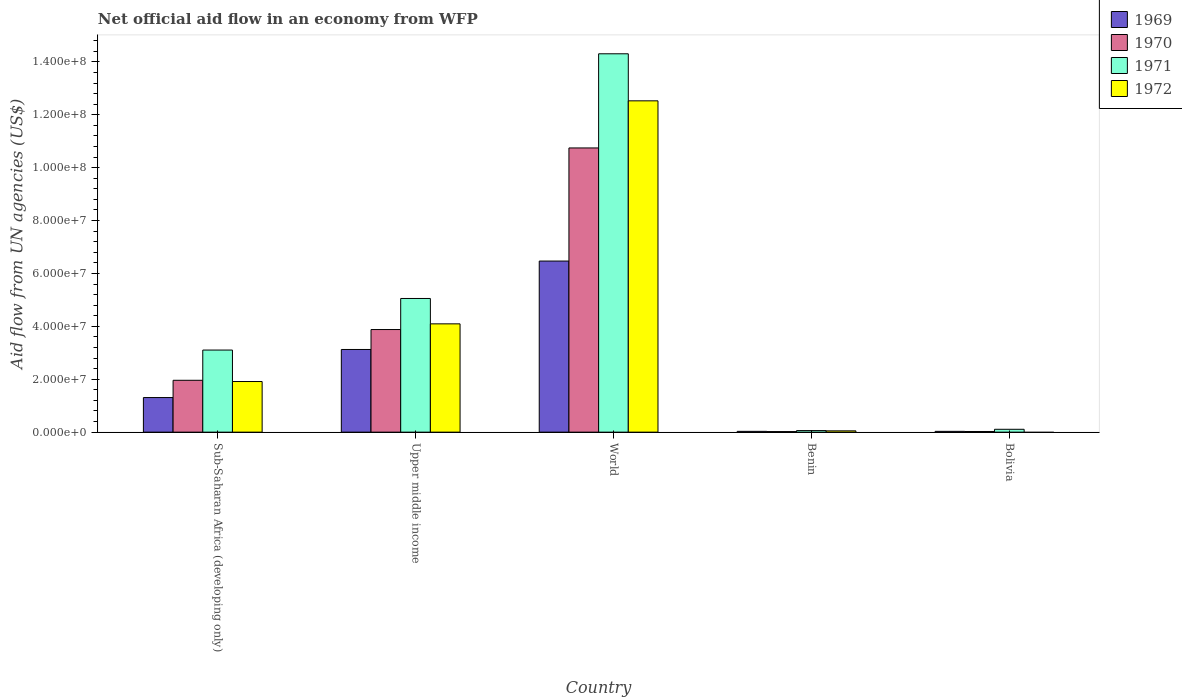Are the number of bars per tick equal to the number of legend labels?
Provide a short and direct response. No. How many bars are there on the 4th tick from the left?
Give a very brief answer. 4. How many bars are there on the 5th tick from the right?
Your response must be concise. 4. What is the label of the 1st group of bars from the left?
Provide a short and direct response. Sub-Saharan Africa (developing only). What is the net official aid flow in 1972 in Benin?
Keep it short and to the point. 4.90e+05. Across all countries, what is the maximum net official aid flow in 1970?
Keep it short and to the point. 1.07e+08. Across all countries, what is the minimum net official aid flow in 1970?
Your answer should be compact. 2.10e+05. In which country was the net official aid flow in 1971 maximum?
Your response must be concise. World. What is the total net official aid flow in 1972 in the graph?
Provide a short and direct response. 1.86e+08. What is the difference between the net official aid flow in 1969 in Sub-Saharan Africa (developing only) and that in Upper middle income?
Your answer should be very brief. -1.82e+07. What is the difference between the net official aid flow in 1970 in Bolivia and the net official aid flow in 1972 in Upper middle income?
Your answer should be very brief. -4.07e+07. What is the average net official aid flow in 1969 per country?
Your answer should be very brief. 2.19e+07. What is the difference between the net official aid flow of/in 1970 and net official aid flow of/in 1969 in World?
Offer a very short reply. 4.28e+07. In how many countries, is the net official aid flow in 1972 greater than 72000000 US$?
Your answer should be compact. 1. What is the ratio of the net official aid flow in 1971 in Sub-Saharan Africa (developing only) to that in World?
Your answer should be very brief. 0.22. Is the difference between the net official aid flow in 1970 in Bolivia and World greater than the difference between the net official aid flow in 1969 in Bolivia and World?
Offer a very short reply. No. What is the difference between the highest and the second highest net official aid flow in 1972?
Give a very brief answer. 1.06e+08. What is the difference between the highest and the lowest net official aid flow in 1971?
Provide a succinct answer. 1.42e+08. Is it the case that in every country, the sum of the net official aid flow in 1970 and net official aid flow in 1972 is greater than the sum of net official aid flow in 1971 and net official aid flow in 1969?
Your answer should be very brief. No. Is it the case that in every country, the sum of the net official aid flow in 1972 and net official aid flow in 1969 is greater than the net official aid flow in 1971?
Offer a very short reply. No. How many bars are there?
Ensure brevity in your answer.  19. How many countries are there in the graph?
Offer a very short reply. 5. What is the difference between two consecutive major ticks on the Y-axis?
Offer a very short reply. 2.00e+07. Does the graph contain any zero values?
Provide a short and direct response. Yes. How many legend labels are there?
Offer a terse response. 4. What is the title of the graph?
Your response must be concise. Net official aid flow in an economy from WFP. Does "1980" appear as one of the legend labels in the graph?
Your response must be concise. No. What is the label or title of the X-axis?
Provide a succinct answer. Country. What is the label or title of the Y-axis?
Your answer should be very brief. Aid flow from UN agencies (US$). What is the Aid flow from UN agencies (US$) in 1969 in Sub-Saharan Africa (developing only)?
Offer a terse response. 1.31e+07. What is the Aid flow from UN agencies (US$) of 1970 in Sub-Saharan Africa (developing only)?
Provide a short and direct response. 1.96e+07. What is the Aid flow from UN agencies (US$) of 1971 in Sub-Saharan Africa (developing only)?
Make the answer very short. 3.10e+07. What is the Aid flow from UN agencies (US$) in 1972 in Sub-Saharan Africa (developing only)?
Offer a terse response. 1.91e+07. What is the Aid flow from UN agencies (US$) in 1969 in Upper middle income?
Your response must be concise. 3.13e+07. What is the Aid flow from UN agencies (US$) in 1970 in Upper middle income?
Make the answer very short. 3.88e+07. What is the Aid flow from UN agencies (US$) in 1971 in Upper middle income?
Your answer should be compact. 5.05e+07. What is the Aid flow from UN agencies (US$) of 1972 in Upper middle income?
Give a very brief answer. 4.10e+07. What is the Aid flow from UN agencies (US$) of 1969 in World?
Keep it short and to the point. 6.47e+07. What is the Aid flow from UN agencies (US$) in 1970 in World?
Your answer should be compact. 1.07e+08. What is the Aid flow from UN agencies (US$) in 1971 in World?
Your response must be concise. 1.43e+08. What is the Aid flow from UN agencies (US$) in 1972 in World?
Give a very brief answer. 1.25e+08. What is the Aid flow from UN agencies (US$) in 1969 in Benin?
Keep it short and to the point. 3.00e+05. What is the Aid flow from UN agencies (US$) of 1970 in Benin?
Your response must be concise. 2.10e+05. What is the Aid flow from UN agencies (US$) of 1971 in Benin?
Your answer should be very brief. 5.90e+05. What is the Aid flow from UN agencies (US$) of 1972 in Benin?
Ensure brevity in your answer.  4.90e+05. What is the Aid flow from UN agencies (US$) in 1971 in Bolivia?
Your answer should be very brief. 1.08e+06. Across all countries, what is the maximum Aid flow from UN agencies (US$) in 1969?
Give a very brief answer. 6.47e+07. Across all countries, what is the maximum Aid flow from UN agencies (US$) in 1970?
Your answer should be compact. 1.07e+08. Across all countries, what is the maximum Aid flow from UN agencies (US$) in 1971?
Provide a succinct answer. 1.43e+08. Across all countries, what is the maximum Aid flow from UN agencies (US$) of 1972?
Your response must be concise. 1.25e+08. Across all countries, what is the minimum Aid flow from UN agencies (US$) of 1970?
Keep it short and to the point. 2.10e+05. Across all countries, what is the minimum Aid flow from UN agencies (US$) in 1971?
Ensure brevity in your answer.  5.90e+05. Across all countries, what is the minimum Aid flow from UN agencies (US$) of 1972?
Your answer should be very brief. 0. What is the total Aid flow from UN agencies (US$) of 1969 in the graph?
Your response must be concise. 1.10e+08. What is the total Aid flow from UN agencies (US$) in 1970 in the graph?
Offer a terse response. 1.66e+08. What is the total Aid flow from UN agencies (US$) in 1971 in the graph?
Make the answer very short. 2.26e+08. What is the total Aid flow from UN agencies (US$) of 1972 in the graph?
Provide a short and direct response. 1.86e+08. What is the difference between the Aid flow from UN agencies (US$) in 1969 in Sub-Saharan Africa (developing only) and that in Upper middle income?
Make the answer very short. -1.82e+07. What is the difference between the Aid flow from UN agencies (US$) of 1970 in Sub-Saharan Africa (developing only) and that in Upper middle income?
Offer a terse response. -1.92e+07. What is the difference between the Aid flow from UN agencies (US$) of 1971 in Sub-Saharan Africa (developing only) and that in Upper middle income?
Ensure brevity in your answer.  -1.95e+07. What is the difference between the Aid flow from UN agencies (US$) in 1972 in Sub-Saharan Africa (developing only) and that in Upper middle income?
Make the answer very short. -2.18e+07. What is the difference between the Aid flow from UN agencies (US$) of 1969 in Sub-Saharan Africa (developing only) and that in World?
Make the answer very short. -5.16e+07. What is the difference between the Aid flow from UN agencies (US$) in 1970 in Sub-Saharan Africa (developing only) and that in World?
Your response must be concise. -8.78e+07. What is the difference between the Aid flow from UN agencies (US$) in 1971 in Sub-Saharan Africa (developing only) and that in World?
Your answer should be very brief. -1.12e+08. What is the difference between the Aid flow from UN agencies (US$) of 1972 in Sub-Saharan Africa (developing only) and that in World?
Provide a succinct answer. -1.06e+08. What is the difference between the Aid flow from UN agencies (US$) in 1969 in Sub-Saharan Africa (developing only) and that in Benin?
Provide a succinct answer. 1.28e+07. What is the difference between the Aid flow from UN agencies (US$) in 1970 in Sub-Saharan Africa (developing only) and that in Benin?
Your response must be concise. 1.94e+07. What is the difference between the Aid flow from UN agencies (US$) in 1971 in Sub-Saharan Africa (developing only) and that in Benin?
Offer a very short reply. 3.04e+07. What is the difference between the Aid flow from UN agencies (US$) of 1972 in Sub-Saharan Africa (developing only) and that in Benin?
Provide a short and direct response. 1.86e+07. What is the difference between the Aid flow from UN agencies (US$) of 1969 in Sub-Saharan Africa (developing only) and that in Bolivia?
Your answer should be very brief. 1.28e+07. What is the difference between the Aid flow from UN agencies (US$) of 1970 in Sub-Saharan Africa (developing only) and that in Bolivia?
Offer a terse response. 1.94e+07. What is the difference between the Aid flow from UN agencies (US$) of 1971 in Sub-Saharan Africa (developing only) and that in Bolivia?
Your answer should be compact. 3.00e+07. What is the difference between the Aid flow from UN agencies (US$) in 1969 in Upper middle income and that in World?
Make the answer very short. -3.34e+07. What is the difference between the Aid flow from UN agencies (US$) in 1970 in Upper middle income and that in World?
Your answer should be compact. -6.87e+07. What is the difference between the Aid flow from UN agencies (US$) of 1971 in Upper middle income and that in World?
Provide a short and direct response. -9.25e+07. What is the difference between the Aid flow from UN agencies (US$) of 1972 in Upper middle income and that in World?
Your answer should be compact. -8.43e+07. What is the difference between the Aid flow from UN agencies (US$) in 1969 in Upper middle income and that in Benin?
Your answer should be compact. 3.10e+07. What is the difference between the Aid flow from UN agencies (US$) in 1970 in Upper middle income and that in Benin?
Provide a succinct answer. 3.86e+07. What is the difference between the Aid flow from UN agencies (US$) of 1971 in Upper middle income and that in Benin?
Your answer should be compact. 5.00e+07. What is the difference between the Aid flow from UN agencies (US$) of 1972 in Upper middle income and that in Benin?
Provide a short and direct response. 4.05e+07. What is the difference between the Aid flow from UN agencies (US$) in 1969 in Upper middle income and that in Bolivia?
Offer a terse response. 3.10e+07. What is the difference between the Aid flow from UN agencies (US$) of 1970 in Upper middle income and that in Bolivia?
Your answer should be very brief. 3.86e+07. What is the difference between the Aid flow from UN agencies (US$) of 1971 in Upper middle income and that in Bolivia?
Offer a very short reply. 4.95e+07. What is the difference between the Aid flow from UN agencies (US$) in 1969 in World and that in Benin?
Your answer should be very brief. 6.44e+07. What is the difference between the Aid flow from UN agencies (US$) in 1970 in World and that in Benin?
Provide a succinct answer. 1.07e+08. What is the difference between the Aid flow from UN agencies (US$) in 1971 in World and that in Benin?
Provide a short and direct response. 1.42e+08. What is the difference between the Aid flow from UN agencies (US$) in 1972 in World and that in Benin?
Make the answer very short. 1.25e+08. What is the difference between the Aid flow from UN agencies (US$) in 1969 in World and that in Bolivia?
Your response must be concise. 6.44e+07. What is the difference between the Aid flow from UN agencies (US$) in 1970 in World and that in Bolivia?
Offer a terse response. 1.07e+08. What is the difference between the Aid flow from UN agencies (US$) in 1971 in World and that in Bolivia?
Provide a short and direct response. 1.42e+08. What is the difference between the Aid flow from UN agencies (US$) of 1969 in Benin and that in Bolivia?
Keep it short and to the point. 0. What is the difference between the Aid flow from UN agencies (US$) in 1970 in Benin and that in Bolivia?
Make the answer very short. -4.00e+04. What is the difference between the Aid flow from UN agencies (US$) of 1971 in Benin and that in Bolivia?
Provide a short and direct response. -4.90e+05. What is the difference between the Aid flow from UN agencies (US$) of 1969 in Sub-Saharan Africa (developing only) and the Aid flow from UN agencies (US$) of 1970 in Upper middle income?
Give a very brief answer. -2.57e+07. What is the difference between the Aid flow from UN agencies (US$) in 1969 in Sub-Saharan Africa (developing only) and the Aid flow from UN agencies (US$) in 1971 in Upper middle income?
Offer a very short reply. -3.75e+07. What is the difference between the Aid flow from UN agencies (US$) in 1969 in Sub-Saharan Africa (developing only) and the Aid flow from UN agencies (US$) in 1972 in Upper middle income?
Make the answer very short. -2.79e+07. What is the difference between the Aid flow from UN agencies (US$) of 1970 in Sub-Saharan Africa (developing only) and the Aid flow from UN agencies (US$) of 1971 in Upper middle income?
Make the answer very short. -3.09e+07. What is the difference between the Aid flow from UN agencies (US$) of 1970 in Sub-Saharan Africa (developing only) and the Aid flow from UN agencies (US$) of 1972 in Upper middle income?
Offer a terse response. -2.13e+07. What is the difference between the Aid flow from UN agencies (US$) of 1971 in Sub-Saharan Africa (developing only) and the Aid flow from UN agencies (US$) of 1972 in Upper middle income?
Your response must be concise. -9.91e+06. What is the difference between the Aid flow from UN agencies (US$) in 1969 in Sub-Saharan Africa (developing only) and the Aid flow from UN agencies (US$) in 1970 in World?
Ensure brevity in your answer.  -9.44e+07. What is the difference between the Aid flow from UN agencies (US$) in 1969 in Sub-Saharan Africa (developing only) and the Aid flow from UN agencies (US$) in 1971 in World?
Make the answer very short. -1.30e+08. What is the difference between the Aid flow from UN agencies (US$) in 1969 in Sub-Saharan Africa (developing only) and the Aid flow from UN agencies (US$) in 1972 in World?
Your response must be concise. -1.12e+08. What is the difference between the Aid flow from UN agencies (US$) of 1970 in Sub-Saharan Africa (developing only) and the Aid flow from UN agencies (US$) of 1971 in World?
Make the answer very short. -1.23e+08. What is the difference between the Aid flow from UN agencies (US$) in 1970 in Sub-Saharan Africa (developing only) and the Aid flow from UN agencies (US$) in 1972 in World?
Keep it short and to the point. -1.06e+08. What is the difference between the Aid flow from UN agencies (US$) in 1971 in Sub-Saharan Africa (developing only) and the Aid flow from UN agencies (US$) in 1972 in World?
Your answer should be very brief. -9.42e+07. What is the difference between the Aid flow from UN agencies (US$) in 1969 in Sub-Saharan Africa (developing only) and the Aid flow from UN agencies (US$) in 1970 in Benin?
Offer a very short reply. 1.29e+07. What is the difference between the Aid flow from UN agencies (US$) in 1969 in Sub-Saharan Africa (developing only) and the Aid flow from UN agencies (US$) in 1971 in Benin?
Offer a terse response. 1.25e+07. What is the difference between the Aid flow from UN agencies (US$) in 1969 in Sub-Saharan Africa (developing only) and the Aid flow from UN agencies (US$) in 1972 in Benin?
Your response must be concise. 1.26e+07. What is the difference between the Aid flow from UN agencies (US$) in 1970 in Sub-Saharan Africa (developing only) and the Aid flow from UN agencies (US$) in 1971 in Benin?
Your answer should be very brief. 1.90e+07. What is the difference between the Aid flow from UN agencies (US$) of 1970 in Sub-Saharan Africa (developing only) and the Aid flow from UN agencies (US$) of 1972 in Benin?
Make the answer very short. 1.91e+07. What is the difference between the Aid flow from UN agencies (US$) of 1971 in Sub-Saharan Africa (developing only) and the Aid flow from UN agencies (US$) of 1972 in Benin?
Keep it short and to the point. 3.06e+07. What is the difference between the Aid flow from UN agencies (US$) in 1969 in Sub-Saharan Africa (developing only) and the Aid flow from UN agencies (US$) in 1970 in Bolivia?
Keep it short and to the point. 1.28e+07. What is the difference between the Aid flow from UN agencies (US$) in 1969 in Sub-Saharan Africa (developing only) and the Aid flow from UN agencies (US$) in 1971 in Bolivia?
Ensure brevity in your answer.  1.20e+07. What is the difference between the Aid flow from UN agencies (US$) in 1970 in Sub-Saharan Africa (developing only) and the Aid flow from UN agencies (US$) in 1971 in Bolivia?
Ensure brevity in your answer.  1.85e+07. What is the difference between the Aid flow from UN agencies (US$) of 1969 in Upper middle income and the Aid flow from UN agencies (US$) of 1970 in World?
Your answer should be very brief. -7.62e+07. What is the difference between the Aid flow from UN agencies (US$) of 1969 in Upper middle income and the Aid flow from UN agencies (US$) of 1971 in World?
Give a very brief answer. -1.12e+08. What is the difference between the Aid flow from UN agencies (US$) in 1969 in Upper middle income and the Aid flow from UN agencies (US$) in 1972 in World?
Make the answer very short. -9.40e+07. What is the difference between the Aid flow from UN agencies (US$) in 1970 in Upper middle income and the Aid flow from UN agencies (US$) in 1971 in World?
Your answer should be very brief. -1.04e+08. What is the difference between the Aid flow from UN agencies (US$) in 1970 in Upper middle income and the Aid flow from UN agencies (US$) in 1972 in World?
Your answer should be compact. -8.65e+07. What is the difference between the Aid flow from UN agencies (US$) in 1971 in Upper middle income and the Aid flow from UN agencies (US$) in 1972 in World?
Keep it short and to the point. -7.47e+07. What is the difference between the Aid flow from UN agencies (US$) of 1969 in Upper middle income and the Aid flow from UN agencies (US$) of 1970 in Benin?
Your answer should be very brief. 3.10e+07. What is the difference between the Aid flow from UN agencies (US$) in 1969 in Upper middle income and the Aid flow from UN agencies (US$) in 1971 in Benin?
Provide a succinct answer. 3.07e+07. What is the difference between the Aid flow from UN agencies (US$) in 1969 in Upper middle income and the Aid flow from UN agencies (US$) in 1972 in Benin?
Offer a very short reply. 3.08e+07. What is the difference between the Aid flow from UN agencies (US$) in 1970 in Upper middle income and the Aid flow from UN agencies (US$) in 1971 in Benin?
Your answer should be very brief. 3.82e+07. What is the difference between the Aid flow from UN agencies (US$) of 1970 in Upper middle income and the Aid flow from UN agencies (US$) of 1972 in Benin?
Offer a very short reply. 3.83e+07. What is the difference between the Aid flow from UN agencies (US$) of 1971 in Upper middle income and the Aid flow from UN agencies (US$) of 1972 in Benin?
Offer a terse response. 5.00e+07. What is the difference between the Aid flow from UN agencies (US$) of 1969 in Upper middle income and the Aid flow from UN agencies (US$) of 1970 in Bolivia?
Your response must be concise. 3.10e+07. What is the difference between the Aid flow from UN agencies (US$) in 1969 in Upper middle income and the Aid flow from UN agencies (US$) in 1971 in Bolivia?
Your answer should be compact. 3.02e+07. What is the difference between the Aid flow from UN agencies (US$) in 1970 in Upper middle income and the Aid flow from UN agencies (US$) in 1971 in Bolivia?
Your answer should be very brief. 3.77e+07. What is the difference between the Aid flow from UN agencies (US$) in 1969 in World and the Aid flow from UN agencies (US$) in 1970 in Benin?
Make the answer very short. 6.45e+07. What is the difference between the Aid flow from UN agencies (US$) of 1969 in World and the Aid flow from UN agencies (US$) of 1971 in Benin?
Provide a succinct answer. 6.41e+07. What is the difference between the Aid flow from UN agencies (US$) of 1969 in World and the Aid flow from UN agencies (US$) of 1972 in Benin?
Provide a succinct answer. 6.42e+07. What is the difference between the Aid flow from UN agencies (US$) in 1970 in World and the Aid flow from UN agencies (US$) in 1971 in Benin?
Keep it short and to the point. 1.07e+08. What is the difference between the Aid flow from UN agencies (US$) of 1970 in World and the Aid flow from UN agencies (US$) of 1972 in Benin?
Your answer should be very brief. 1.07e+08. What is the difference between the Aid flow from UN agencies (US$) in 1971 in World and the Aid flow from UN agencies (US$) in 1972 in Benin?
Keep it short and to the point. 1.43e+08. What is the difference between the Aid flow from UN agencies (US$) in 1969 in World and the Aid flow from UN agencies (US$) in 1970 in Bolivia?
Keep it short and to the point. 6.44e+07. What is the difference between the Aid flow from UN agencies (US$) of 1969 in World and the Aid flow from UN agencies (US$) of 1971 in Bolivia?
Ensure brevity in your answer.  6.36e+07. What is the difference between the Aid flow from UN agencies (US$) of 1970 in World and the Aid flow from UN agencies (US$) of 1971 in Bolivia?
Offer a very short reply. 1.06e+08. What is the difference between the Aid flow from UN agencies (US$) of 1969 in Benin and the Aid flow from UN agencies (US$) of 1970 in Bolivia?
Provide a short and direct response. 5.00e+04. What is the difference between the Aid flow from UN agencies (US$) in 1969 in Benin and the Aid flow from UN agencies (US$) in 1971 in Bolivia?
Provide a short and direct response. -7.80e+05. What is the difference between the Aid flow from UN agencies (US$) of 1970 in Benin and the Aid flow from UN agencies (US$) of 1971 in Bolivia?
Offer a terse response. -8.70e+05. What is the average Aid flow from UN agencies (US$) of 1969 per country?
Keep it short and to the point. 2.19e+07. What is the average Aid flow from UN agencies (US$) in 1970 per country?
Keep it short and to the point. 3.33e+07. What is the average Aid flow from UN agencies (US$) in 1971 per country?
Give a very brief answer. 4.53e+07. What is the average Aid flow from UN agencies (US$) in 1972 per country?
Provide a succinct answer. 3.72e+07. What is the difference between the Aid flow from UN agencies (US$) in 1969 and Aid flow from UN agencies (US$) in 1970 in Sub-Saharan Africa (developing only)?
Make the answer very short. -6.53e+06. What is the difference between the Aid flow from UN agencies (US$) of 1969 and Aid flow from UN agencies (US$) of 1971 in Sub-Saharan Africa (developing only)?
Your answer should be compact. -1.80e+07. What is the difference between the Aid flow from UN agencies (US$) of 1969 and Aid flow from UN agencies (US$) of 1972 in Sub-Saharan Africa (developing only)?
Your response must be concise. -6.06e+06. What is the difference between the Aid flow from UN agencies (US$) in 1970 and Aid flow from UN agencies (US$) in 1971 in Sub-Saharan Africa (developing only)?
Offer a terse response. -1.14e+07. What is the difference between the Aid flow from UN agencies (US$) in 1970 and Aid flow from UN agencies (US$) in 1972 in Sub-Saharan Africa (developing only)?
Provide a succinct answer. 4.70e+05. What is the difference between the Aid flow from UN agencies (US$) of 1971 and Aid flow from UN agencies (US$) of 1972 in Sub-Saharan Africa (developing only)?
Make the answer very short. 1.19e+07. What is the difference between the Aid flow from UN agencies (US$) in 1969 and Aid flow from UN agencies (US$) in 1970 in Upper middle income?
Your answer should be compact. -7.54e+06. What is the difference between the Aid flow from UN agencies (US$) of 1969 and Aid flow from UN agencies (US$) of 1971 in Upper middle income?
Keep it short and to the point. -1.93e+07. What is the difference between the Aid flow from UN agencies (US$) of 1969 and Aid flow from UN agencies (US$) of 1972 in Upper middle income?
Your response must be concise. -9.69e+06. What is the difference between the Aid flow from UN agencies (US$) in 1970 and Aid flow from UN agencies (US$) in 1971 in Upper middle income?
Ensure brevity in your answer.  -1.17e+07. What is the difference between the Aid flow from UN agencies (US$) of 1970 and Aid flow from UN agencies (US$) of 1972 in Upper middle income?
Give a very brief answer. -2.15e+06. What is the difference between the Aid flow from UN agencies (US$) in 1971 and Aid flow from UN agencies (US$) in 1972 in Upper middle income?
Your answer should be compact. 9.59e+06. What is the difference between the Aid flow from UN agencies (US$) of 1969 and Aid flow from UN agencies (US$) of 1970 in World?
Offer a very short reply. -4.28e+07. What is the difference between the Aid flow from UN agencies (US$) of 1969 and Aid flow from UN agencies (US$) of 1971 in World?
Make the answer very short. -7.84e+07. What is the difference between the Aid flow from UN agencies (US$) of 1969 and Aid flow from UN agencies (US$) of 1972 in World?
Your answer should be very brief. -6.06e+07. What is the difference between the Aid flow from UN agencies (US$) of 1970 and Aid flow from UN agencies (US$) of 1971 in World?
Give a very brief answer. -3.56e+07. What is the difference between the Aid flow from UN agencies (US$) in 1970 and Aid flow from UN agencies (US$) in 1972 in World?
Give a very brief answer. -1.78e+07. What is the difference between the Aid flow from UN agencies (US$) of 1971 and Aid flow from UN agencies (US$) of 1972 in World?
Your answer should be very brief. 1.78e+07. What is the difference between the Aid flow from UN agencies (US$) of 1969 and Aid flow from UN agencies (US$) of 1970 in Benin?
Your response must be concise. 9.00e+04. What is the difference between the Aid flow from UN agencies (US$) of 1969 and Aid flow from UN agencies (US$) of 1971 in Benin?
Offer a very short reply. -2.90e+05. What is the difference between the Aid flow from UN agencies (US$) in 1970 and Aid flow from UN agencies (US$) in 1971 in Benin?
Give a very brief answer. -3.80e+05. What is the difference between the Aid flow from UN agencies (US$) of 1970 and Aid flow from UN agencies (US$) of 1972 in Benin?
Offer a terse response. -2.80e+05. What is the difference between the Aid flow from UN agencies (US$) of 1971 and Aid flow from UN agencies (US$) of 1972 in Benin?
Offer a terse response. 1.00e+05. What is the difference between the Aid flow from UN agencies (US$) of 1969 and Aid flow from UN agencies (US$) of 1971 in Bolivia?
Keep it short and to the point. -7.80e+05. What is the difference between the Aid flow from UN agencies (US$) in 1970 and Aid flow from UN agencies (US$) in 1971 in Bolivia?
Offer a very short reply. -8.30e+05. What is the ratio of the Aid flow from UN agencies (US$) in 1969 in Sub-Saharan Africa (developing only) to that in Upper middle income?
Provide a short and direct response. 0.42. What is the ratio of the Aid flow from UN agencies (US$) of 1970 in Sub-Saharan Africa (developing only) to that in Upper middle income?
Your response must be concise. 0.51. What is the ratio of the Aid flow from UN agencies (US$) of 1971 in Sub-Saharan Africa (developing only) to that in Upper middle income?
Ensure brevity in your answer.  0.61. What is the ratio of the Aid flow from UN agencies (US$) of 1972 in Sub-Saharan Africa (developing only) to that in Upper middle income?
Your answer should be compact. 0.47. What is the ratio of the Aid flow from UN agencies (US$) of 1969 in Sub-Saharan Africa (developing only) to that in World?
Keep it short and to the point. 0.2. What is the ratio of the Aid flow from UN agencies (US$) of 1970 in Sub-Saharan Africa (developing only) to that in World?
Your response must be concise. 0.18. What is the ratio of the Aid flow from UN agencies (US$) of 1971 in Sub-Saharan Africa (developing only) to that in World?
Give a very brief answer. 0.22. What is the ratio of the Aid flow from UN agencies (US$) in 1972 in Sub-Saharan Africa (developing only) to that in World?
Your response must be concise. 0.15. What is the ratio of the Aid flow from UN agencies (US$) of 1969 in Sub-Saharan Africa (developing only) to that in Benin?
Ensure brevity in your answer.  43.6. What is the ratio of the Aid flow from UN agencies (US$) in 1970 in Sub-Saharan Africa (developing only) to that in Benin?
Your answer should be very brief. 93.38. What is the ratio of the Aid flow from UN agencies (US$) of 1971 in Sub-Saharan Africa (developing only) to that in Benin?
Make the answer very short. 52.61. What is the ratio of the Aid flow from UN agencies (US$) of 1972 in Sub-Saharan Africa (developing only) to that in Benin?
Ensure brevity in your answer.  39.06. What is the ratio of the Aid flow from UN agencies (US$) in 1969 in Sub-Saharan Africa (developing only) to that in Bolivia?
Your answer should be compact. 43.6. What is the ratio of the Aid flow from UN agencies (US$) in 1970 in Sub-Saharan Africa (developing only) to that in Bolivia?
Make the answer very short. 78.44. What is the ratio of the Aid flow from UN agencies (US$) in 1971 in Sub-Saharan Africa (developing only) to that in Bolivia?
Your response must be concise. 28.74. What is the ratio of the Aid flow from UN agencies (US$) in 1969 in Upper middle income to that in World?
Give a very brief answer. 0.48. What is the ratio of the Aid flow from UN agencies (US$) of 1970 in Upper middle income to that in World?
Provide a short and direct response. 0.36. What is the ratio of the Aid flow from UN agencies (US$) in 1971 in Upper middle income to that in World?
Provide a short and direct response. 0.35. What is the ratio of the Aid flow from UN agencies (US$) of 1972 in Upper middle income to that in World?
Provide a short and direct response. 0.33. What is the ratio of the Aid flow from UN agencies (US$) in 1969 in Upper middle income to that in Benin?
Your answer should be very brief. 104.2. What is the ratio of the Aid flow from UN agencies (US$) of 1970 in Upper middle income to that in Benin?
Make the answer very short. 184.76. What is the ratio of the Aid flow from UN agencies (US$) in 1971 in Upper middle income to that in Benin?
Your answer should be compact. 85.66. What is the ratio of the Aid flow from UN agencies (US$) in 1972 in Upper middle income to that in Benin?
Provide a short and direct response. 83.57. What is the ratio of the Aid flow from UN agencies (US$) of 1969 in Upper middle income to that in Bolivia?
Provide a succinct answer. 104.2. What is the ratio of the Aid flow from UN agencies (US$) of 1970 in Upper middle income to that in Bolivia?
Give a very brief answer. 155.2. What is the ratio of the Aid flow from UN agencies (US$) in 1971 in Upper middle income to that in Bolivia?
Keep it short and to the point. 46.8. What is the ratio of the Aid flow from UN agencies (US$) of 1969 in World to that in Benin?
Your answer should be very brief. 215.63. What is the ratio of the Aid flow from UN agencies (US$) of 1970 in World to that in Benin?
Your response must be concise. 511.71. What is the ratio of the Aid flow from UN agencies (US$) in 1971 in World to that in Benin?
Ensure brevity in your answer.  242.47. What is the ratio of the Aid flow from UN agencies (US$) in 1972 in World to that in Benin?
Offer a terse response. 255.65. What is the ratio of the Aid flow from UN agencies (US$) in 1969 in World to that in Bolivia?
Keep it short and to the point. 215.63. What is the ratio of the Aid flow from UN agencies (US$) of 1970 in World to that in Bolivia?
Your answer should be very brief. 429.84. What is the ratio of the Aid flow from UN agencies (US$) in 1971 in World to that in Bolivia?
Provide a succinct answer. 132.46. What is the ratio of the Aid flow from UN agencies (US$) of 1970 in Benin to that in Bolivia?
Your answer should be compact. 0.84. What is the ratio of the Aid flow from UN agencies (US$) of 1971 in Benin to that in Bolivia?
Make the answer very short. 0.55. What is the difference between the highest and the second highest Aid flow from UN agencies (US$) in 1969?
Give a very brief answer. 3.34e+07. What is the difference between the highest and the second highest Aid flow from UN agencies (US$) in 1970?
Your answer should be very brief. 6.87e+07. What is the difference between the highest and the second highest Aid flow from UN agencies (US$) in 1971?
Keep it short and to the point. 9.25e+07. What is the difference between the highest and the second highest Aid flow from UN agencies (US$) in 1972?
Ensure brevity in your answer.  8.43e+07. What is the difference between the highest and the lowest Aid flow from UN agencies (US$) in 1969?
Provide a succinct answer. 6.44e+07. What is the difference between the highest and the lowest Aid flow from UN agencies (US$) of 1970?
Your answer should be very brief. 1.07e+08. What is the difference between the highest and the lowest Aid flow from UN agencies (US$) in 1971?
Your response must be concise. 1.42e+08. What is the difference between the highest and the lowest Aid flow from UN agencies (US$) in 1972?
Offer a terse response. 1.25e+08. 